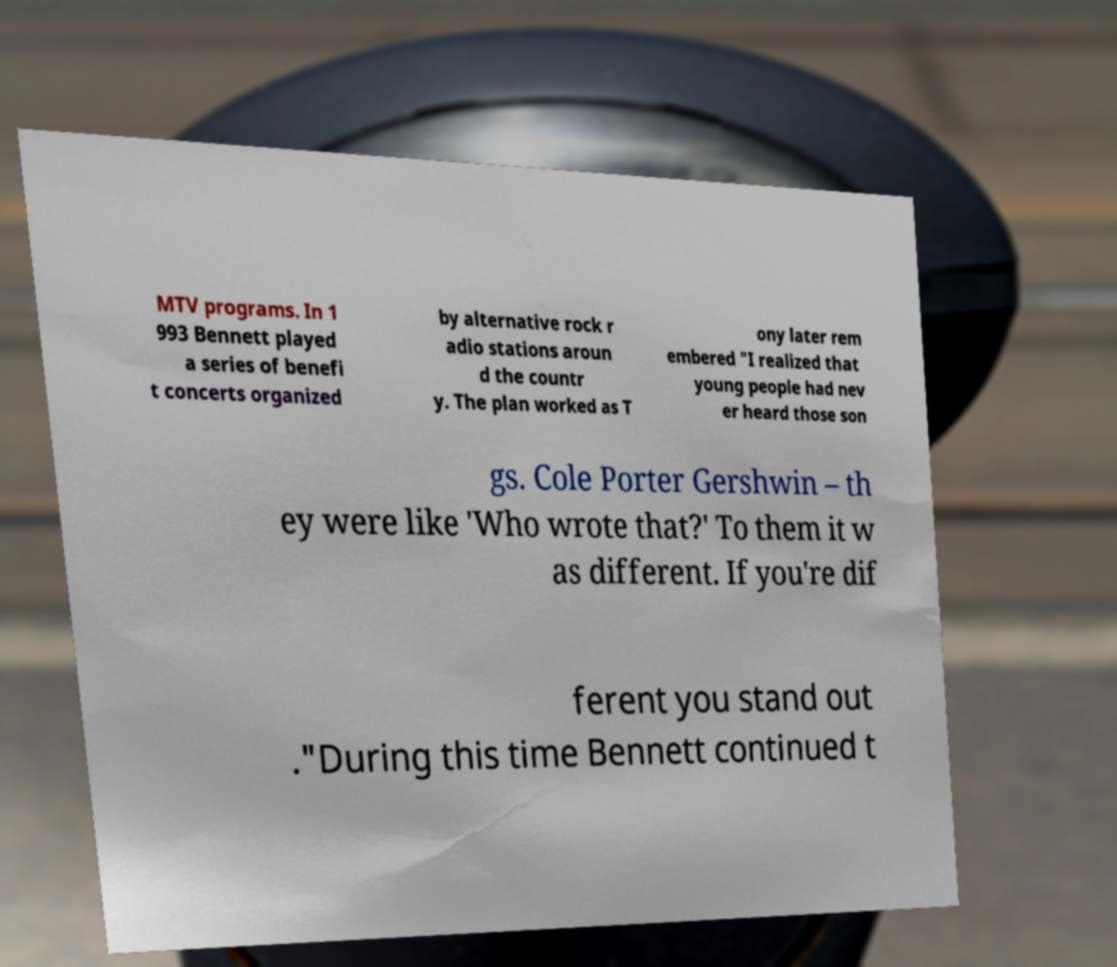For documentation purposes, I need the text within this image transcribed. Could you provide that? MTV programs. In 1 993 Bennett played a series of benefi t concerts organized by alternative rock r adio stations aroun d the countr y. The plan worked as T ony later rem embered "I realized that young people had nev er heard those son gs. Cole Porter Gershwin – th ey were like 'Who wrote that?' To them it w as different. If you're dif ferent you stand out ."During this time Bennett continued t 